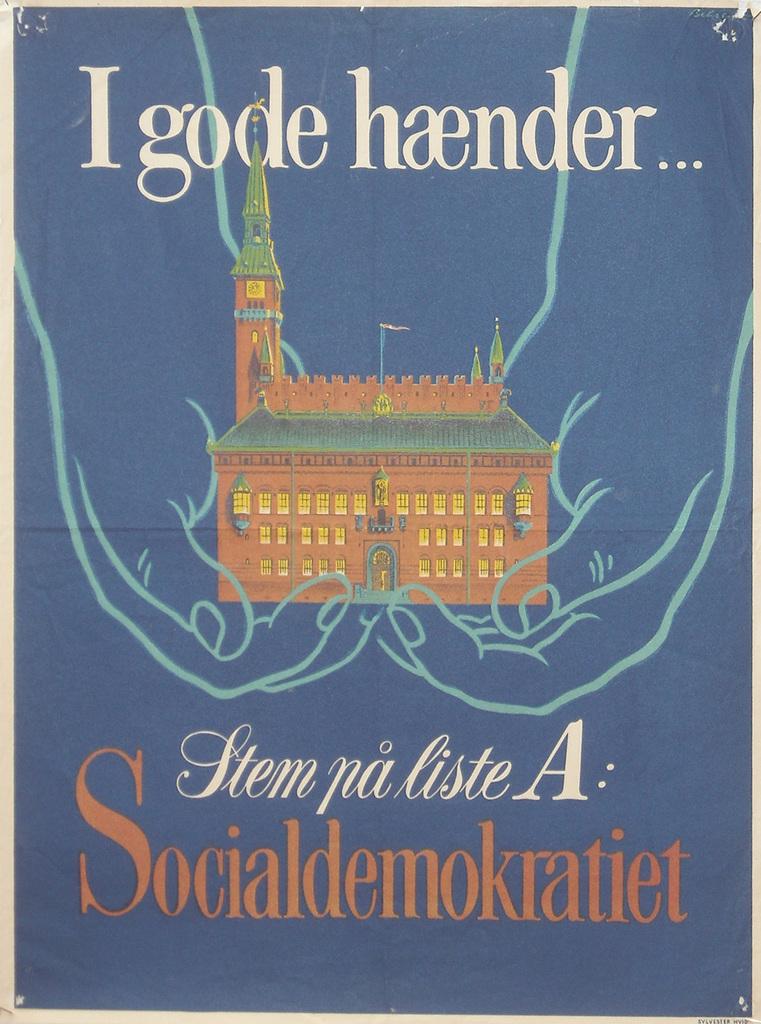What is the title of this book?
Your response must be concise. Igode haender. 